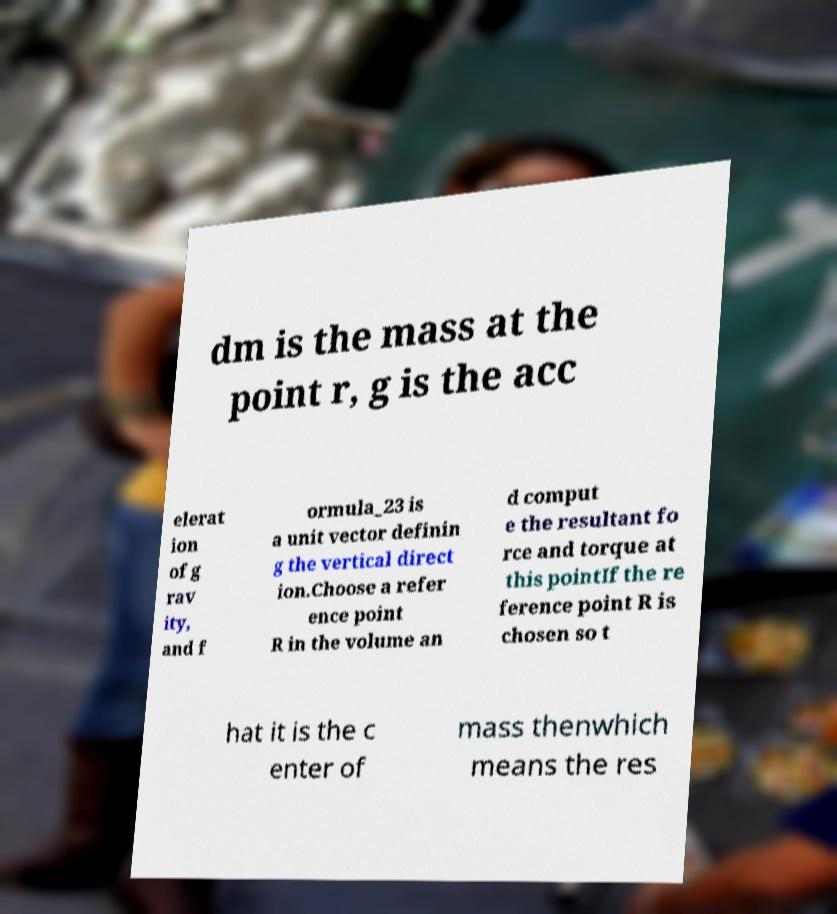What messages or text are displayed in this image? I need them in a readable, typed format. dm is the mass at the point r, g is the acc elerat ion of g rav ity, and f ormula_23 is a unit vector definin g the vertical direct ion.Choose a refer ence point R in the volume an d comput e the resultant fo rce and torque at this pointIf the re ference point R is chosen so t hat it is the c enter of mass thenwhich means the res 